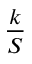<formula> <loc_0><loc_0><loc_500><loc_500>\frac { k } { S }</formula> 